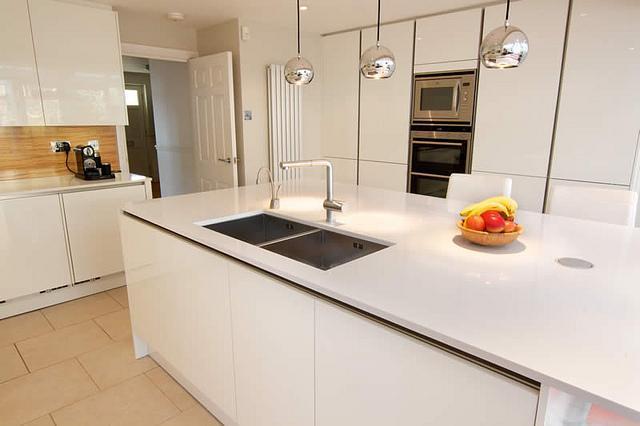How many skylights can be seen?
Give a very brief answer. 0. How many microwaves are there?
Give a very brief answer. 1. 